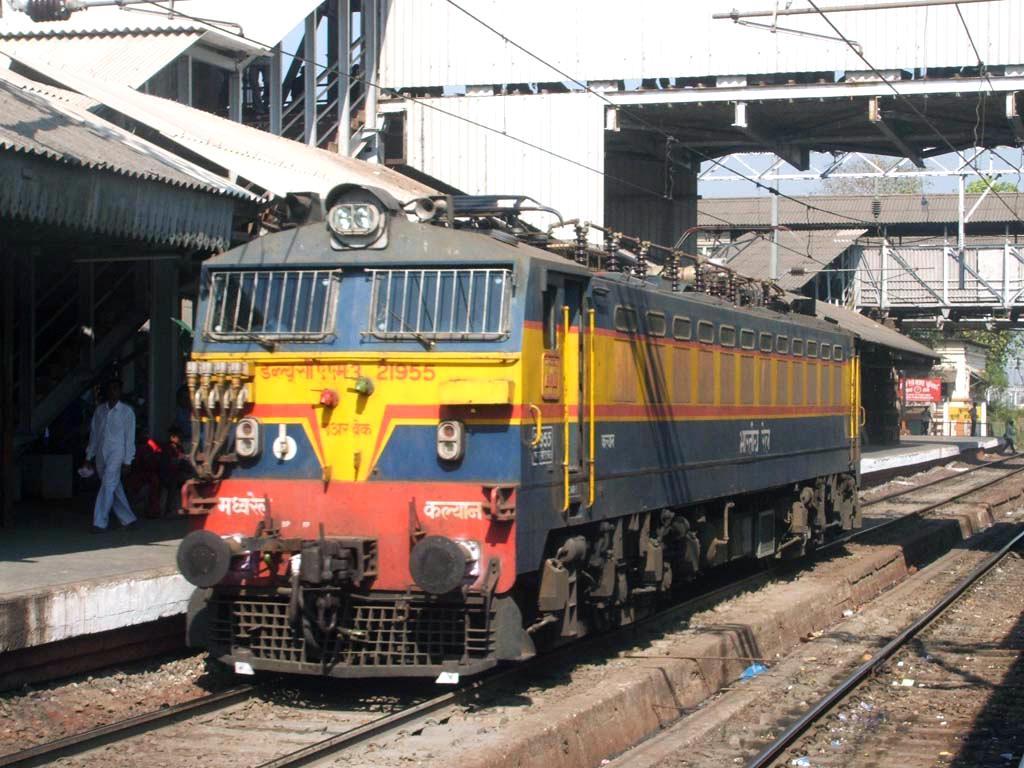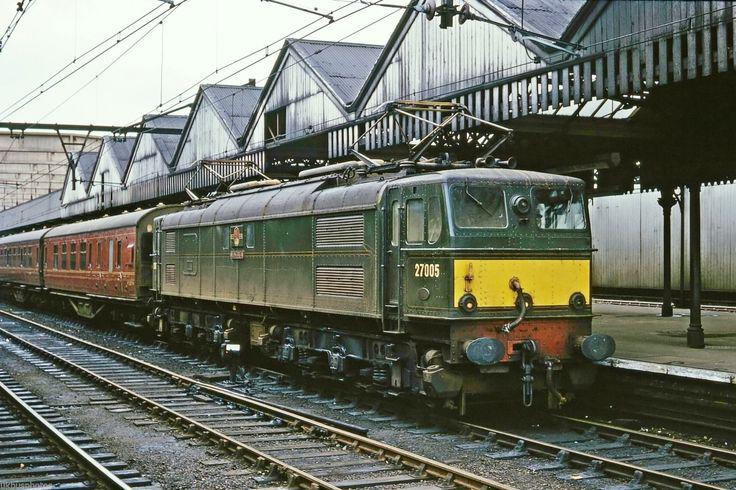The first image is the image on the left, the second image is the image on the right. Examine the images to the left and right. Is the description "The right image shows a train with the front car colored red and yellow." accurate? Answer yes or no. No. 